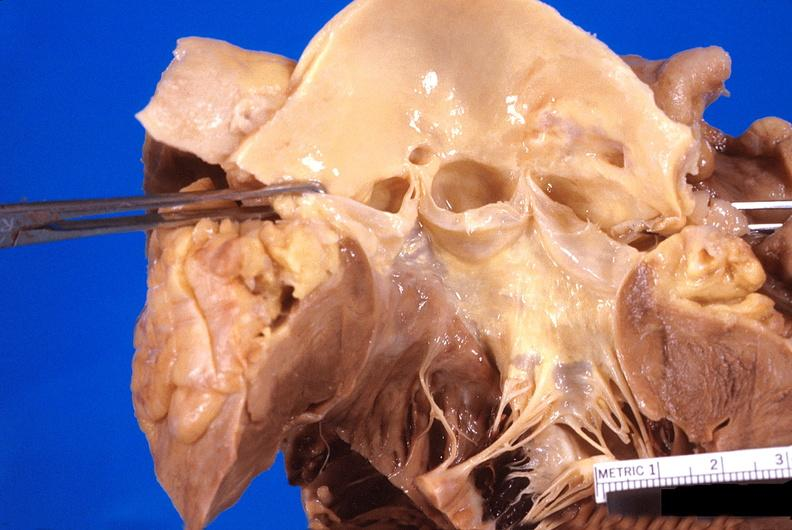s heart present?
Answer the question using a single word or phrase. Yes 